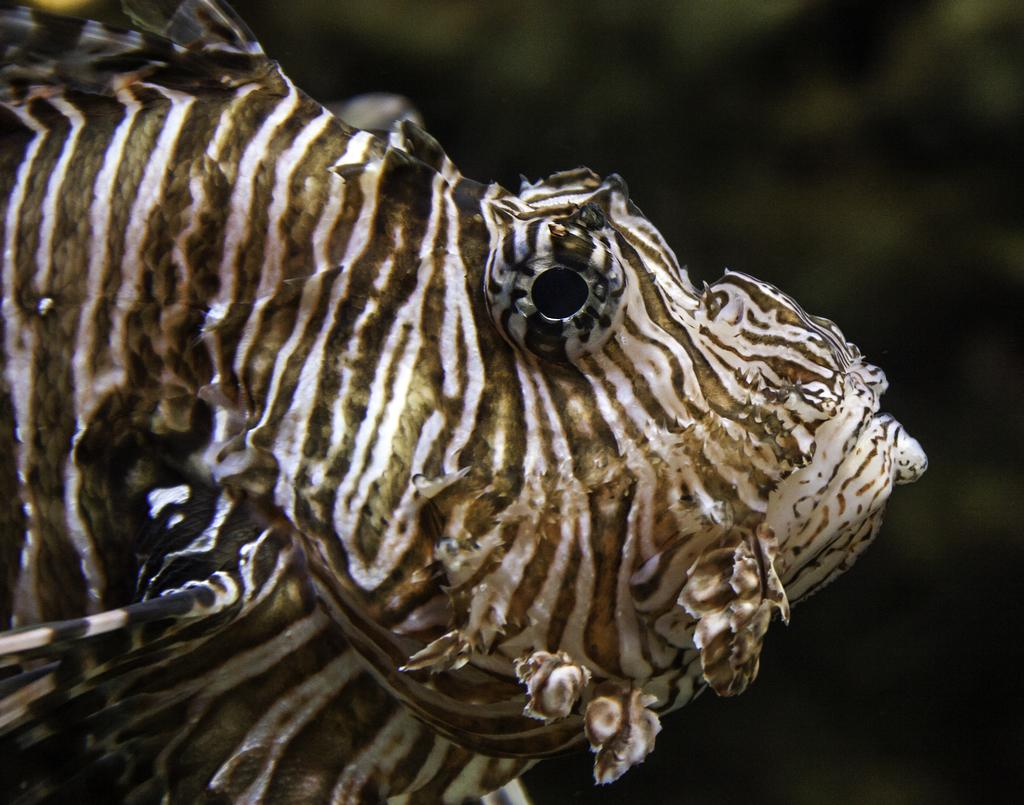What type of animal is present in the image? There is an animal in the image, but the specific type of animal cannot be determined from the provided fact. What type of bell is the animal wearing in the image? There is no bell present in the image, and the animal's attire cannot be determined from the provided fact. 